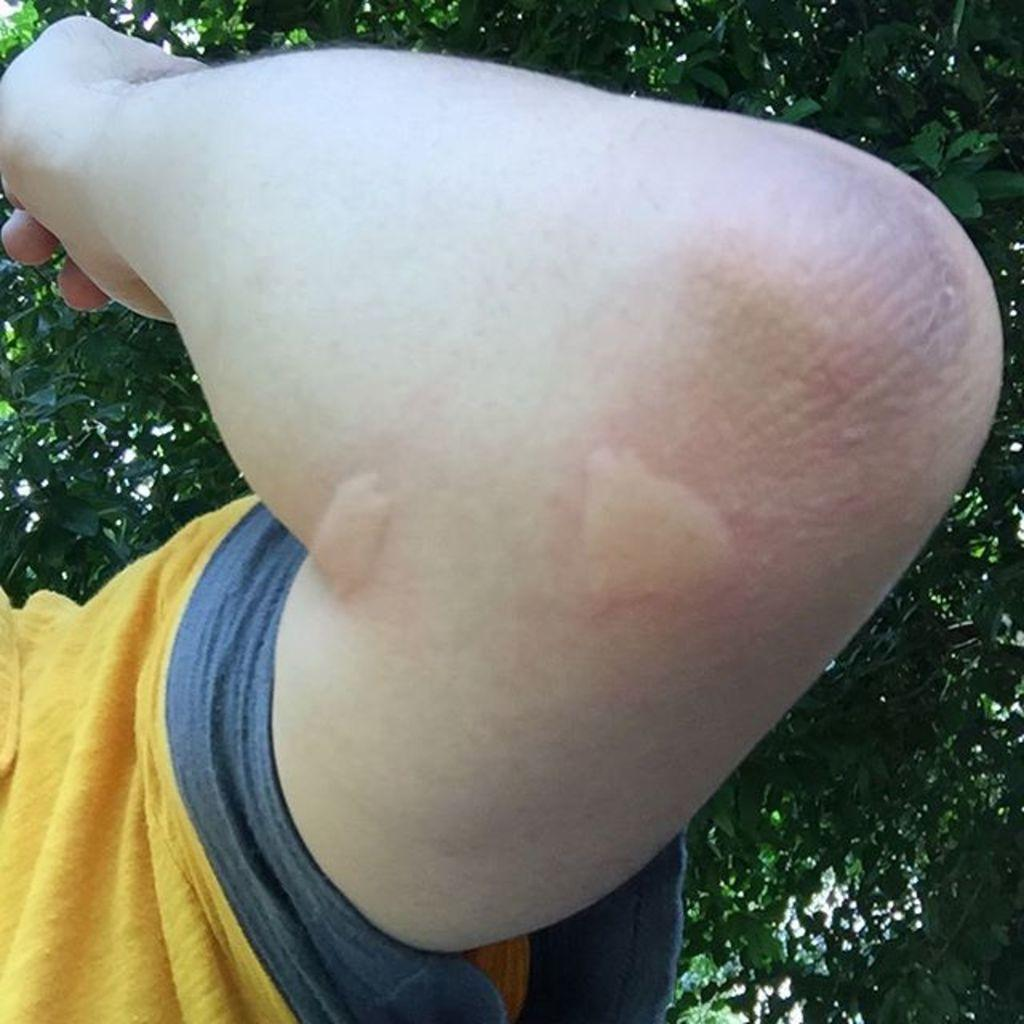What can be seen in the image? There is a hand in the image. What is the person wearing? The person is wearing a yellow shirt. What can be seen in the distance in the image? There are trees in the background of the image. What type of grape is being held by the person in the image? There is no grape present in the image; only a hand and a yellow shirt are visible. 